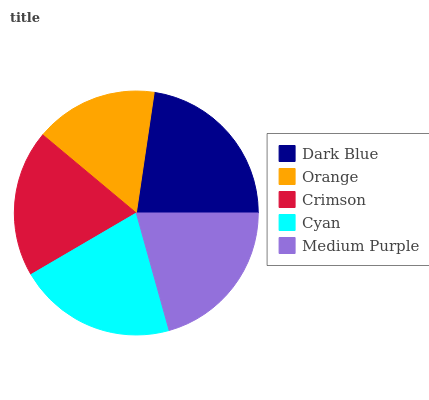Is Orange the minimum?
Answer yes or no. Yes. Is Dark Blue the maximum?
Answer yes or no. Yes. Is Crimson the minimum?
Answer yes or no. No. Is Crimson the maximum?
Answer yes or no. No. Is Crimson greater than Orange?
Answer yes or no. Yes. Is Orange less than Crimson?
Answer yes or no. Yes. Is Orange greater than Crimson?
Answer yes or no. No. Is Crimson less than Orange?
Answer yes or no. No. Is Medium Purple the high median?
Answer yes or no. Yes. Is Medium Purple the low median?
Answer yes or no. Yes. Is Orange the high median?
Answer yes or no. No. Is Crimson the low median?
Answer yes or no. No. 